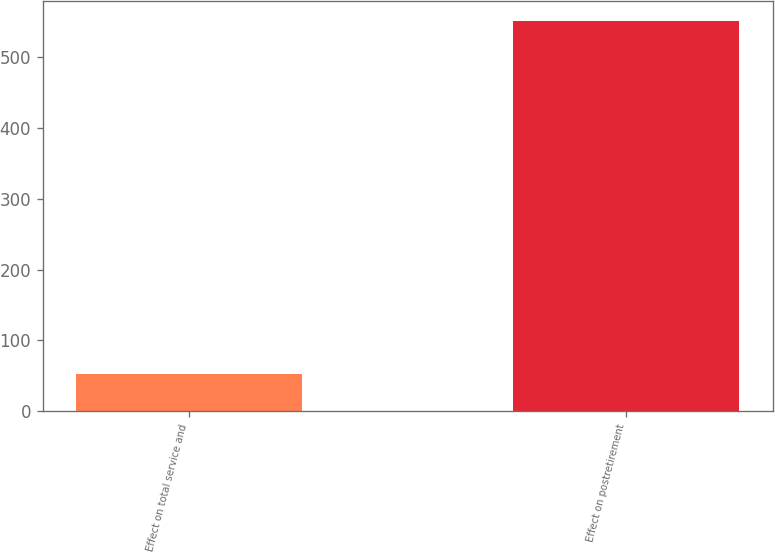Convert chart. <chart><loc_0><loc_0><loc_500><loc_500><bar_chart><fcel>Effect on total service and<fcel>Effect on postretirement<nl><fcel>52<fcel>552<nl></chart> 